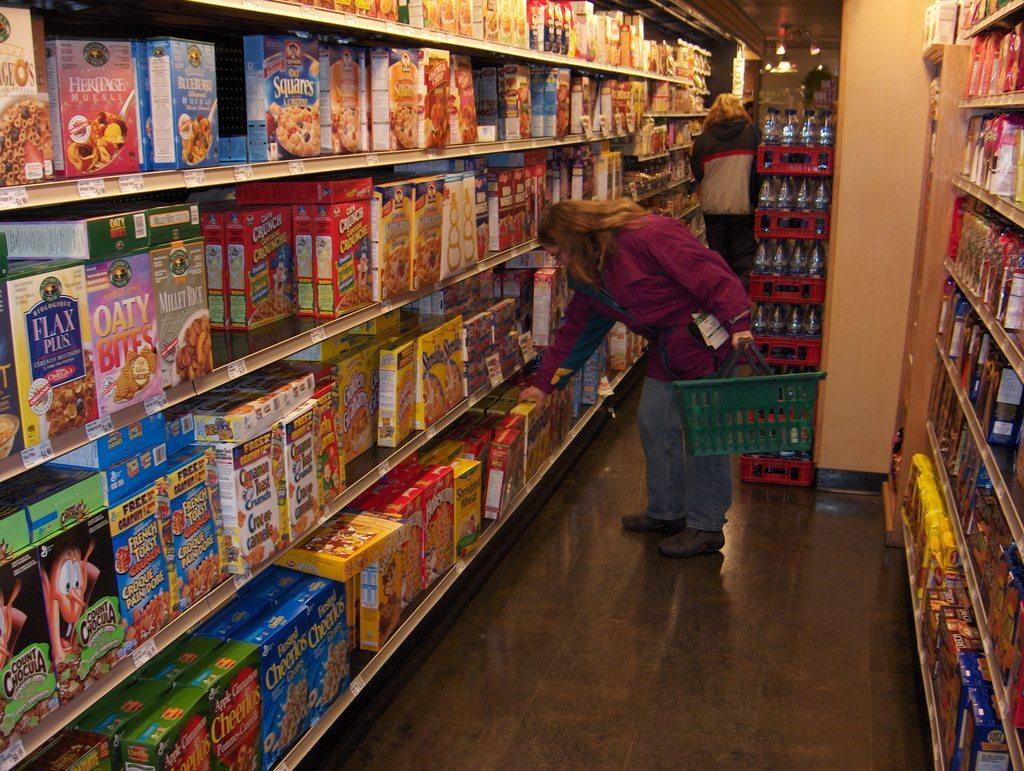<image>
Describe the image concisely. Person shopping for ceral with one that says "OATY" on the front. 